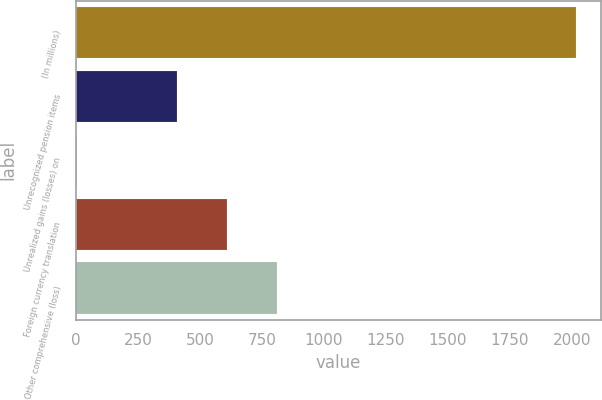Convert chart to OTSL. <chart><loc_0><loc_0><loc_500><loc_500><bar_chart><fcel>(In millions)<fcel>Unrecognized pension items<fcel>Unrealized gains (losses) on<fcel>Foreign currency translation<fcel>Other comprehensive (loss)<nl><fcel>2018<fcel>406.72<fcel>3.9<fcel>608.13<fcel>809.54<nl></chart> 